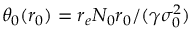Convert formula to latex. <formula><loc_0><loc_0><loc_500><loc_500>\theta _ { 0 } ( r _ { 0 } ) = r _ { e } N _ { 0 } r _ { 0 } / ( \gamma \sigma _ { 0 } ^ { 2 } )</formula> 